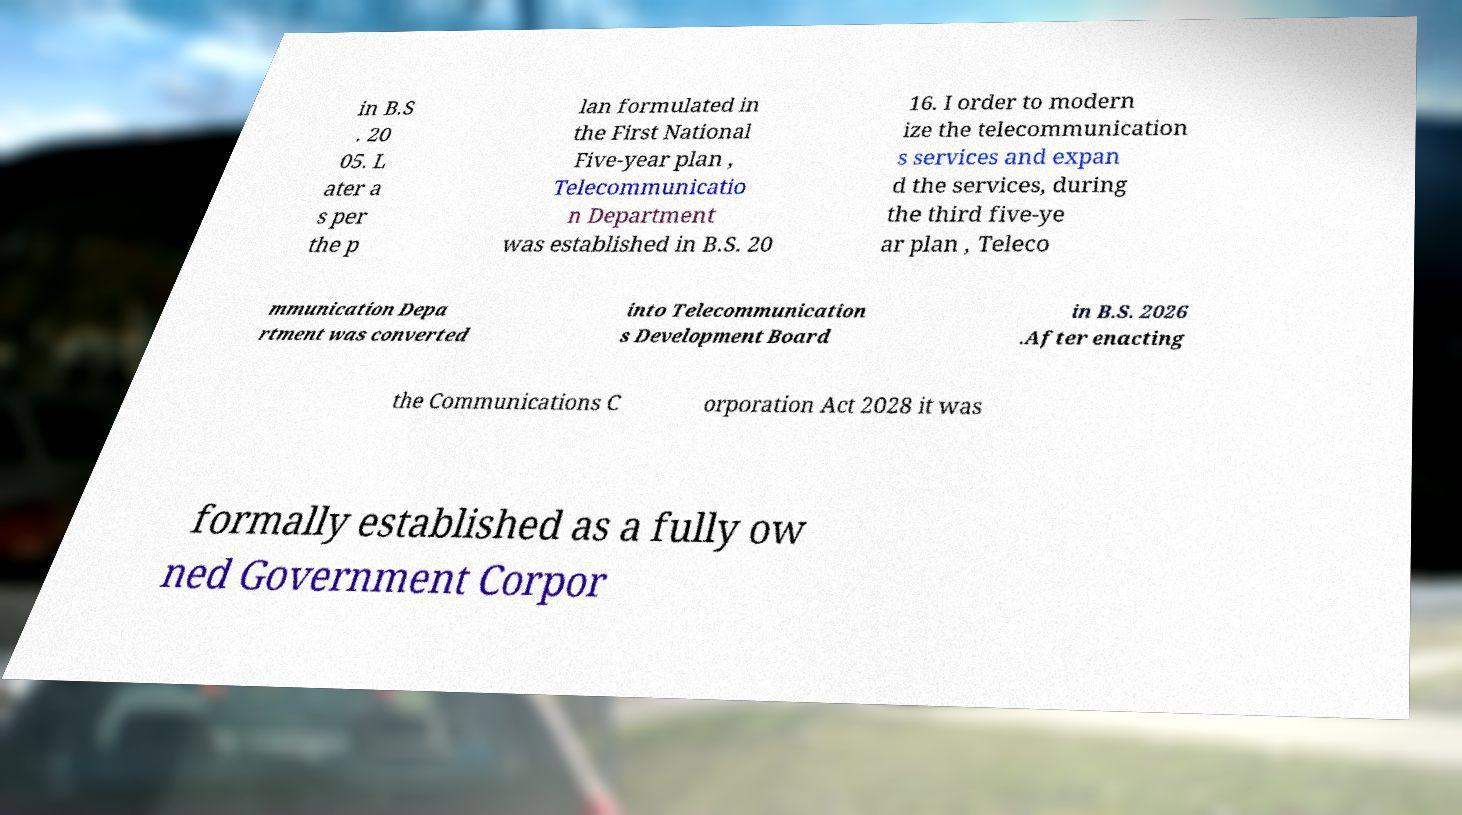Could you extract and type out the text from this image? in B.S . 20 05. L ater a s per the p lan formulated in the First National Five-year plan , Telecommunicatio n Department was established in B.S. 20 16. I order to modern ize the telecommunication s services and expan d the services, during the third five-ye ar plan , Teleco mmunication Depa rtment was converted into Telecommunication s Development Board in B.S. 2026 .After enacting the Communications C orporation Act 2028 it was formally established as a fully ow ned Government Corpor 